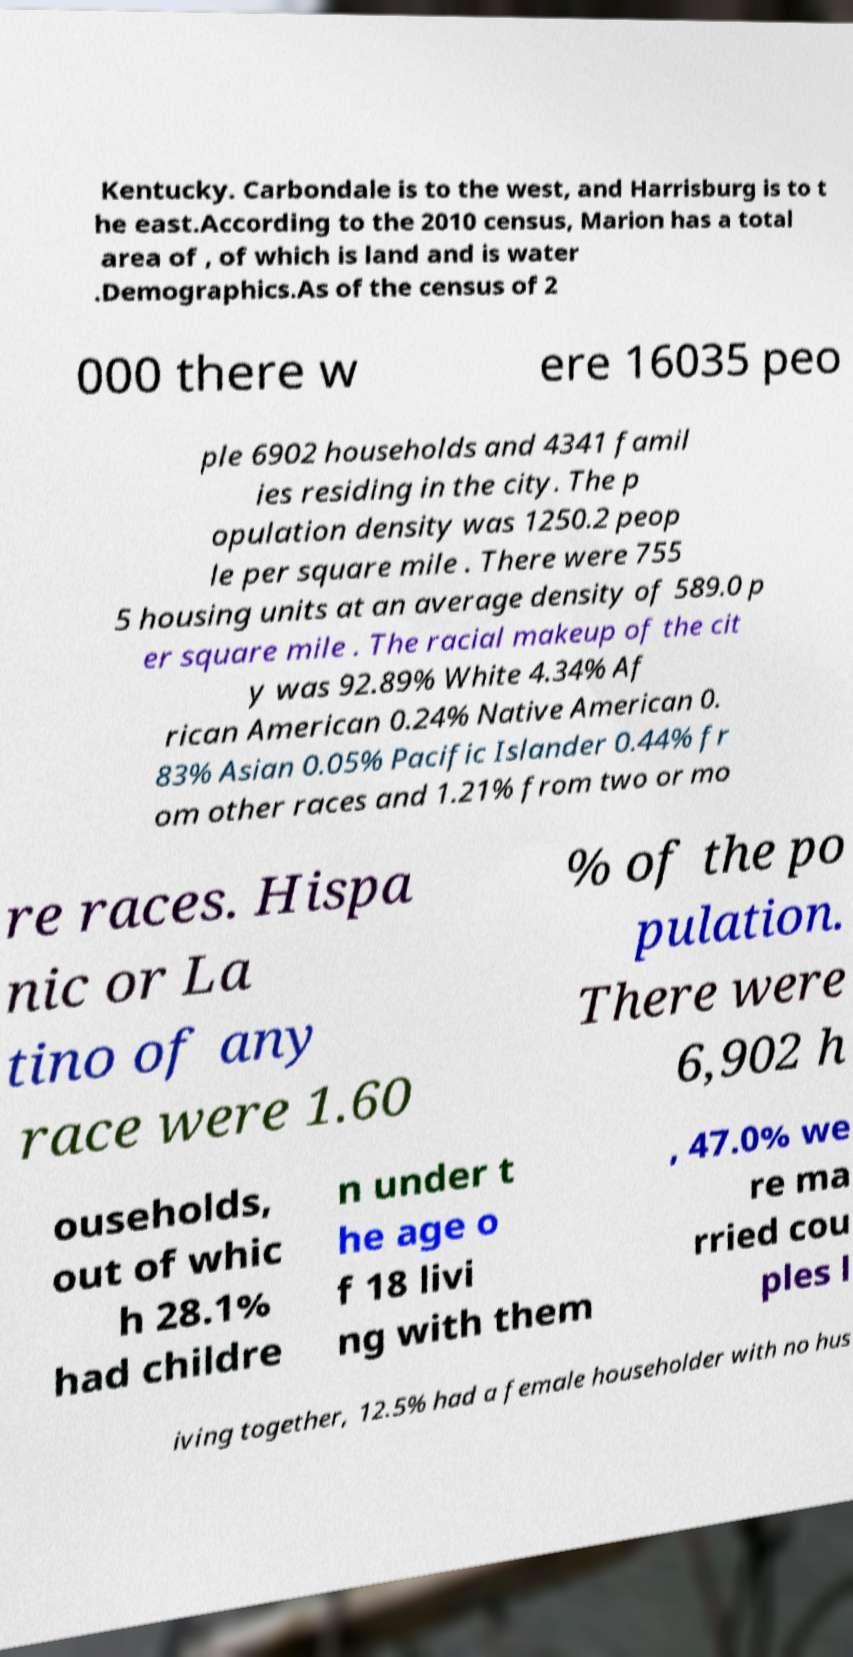Could you extract and type out the text from this image? Kentucky. Carbondale is to the west, and Harrisburg is to t he east.According to the 2010 census, Marion has a total area of , of which is land and is water .Demographics.As of the census of 2 000 there w ere 16035 peo ple 6902 households and 4341 famil ies residing in the city. The p opulation density was 1250.2 peop le per square mile . There were 755 5 housing units at an average density of 589.0 p er square mile . The racial makeup of the cit y was 92.89% White 4.34% Af rican American 0.24% Native American 0. 83% Asian 0.05% Pacific Islander 0.44% fr om other races and 1.21% from two or mo re races. Hispa nic or La tino of any race were 1.60 % of the po pulation. There were 6,902 h ouseholds, out of whic h 28.1% had childre n under t he age o f 18 livi ng with them , 47.0% we re ma rried cou ples l iving together, 12.5% had a female householder with no hus 